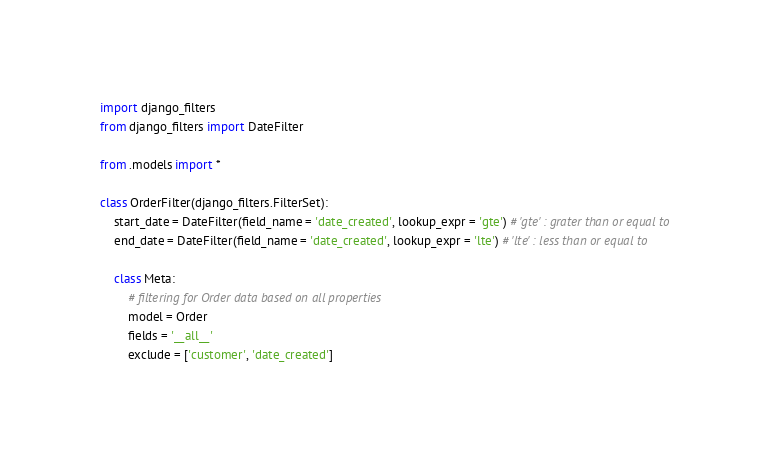<code> <loc_0><loc_0><loc_500><loc_500><_Python_>import django_filters
from django_filters import DateFilter

from .models import *

class OrderFilter(django_filters.FilterSet):
    start_date = DateFilter(field_name = 'date_created', lookup_expr = 'gte') # 'gte' : grater than or equal to
    end_date = DateFilter(field_name = 'date_created', lookup_expr = 'lte') # 'lte' : less than or equal to

    class Meta:
        # filtering for Order data based on all properties
        model = Order
        fields = '__all__'
        exclude = ['customer', 'date_created']
</code> 